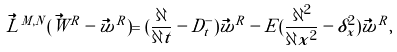<formula> <loc_0><loc_0><loc_500><loc_500>\vec { L } ^ { M , N } ( \vec { W } ^ { R } - \vec { w } ^ { R } ) = ( \frac { \partial } { \partial t } - D ^ { - } _ { t } ) \vec { w } ^ { R } - E ( \frac { \partial ^ { 2 } } { \partial x ^ { 2 } } - \delta ^ { 2 } _ { x } ) \vec { w } ^ { R } ,</formula> 